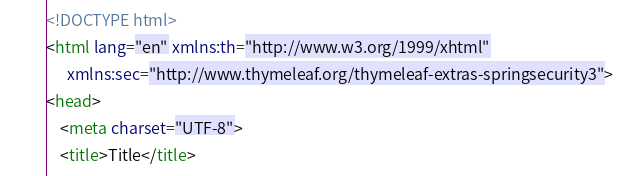Convert code to text. <code><loc_0><loc_0><loc_500><loc_500><_HTML_><!DOCTYPE html>
<html lang="en" xmlns:th="http://www.w3.org/1999/xhtml"
      xmlns:sec="http://www.thymeleaf.org/thymeleaf-extras-springsecurity3">
<head>
    <meta charset="UTF-8">
    <title>Title</title></code> 